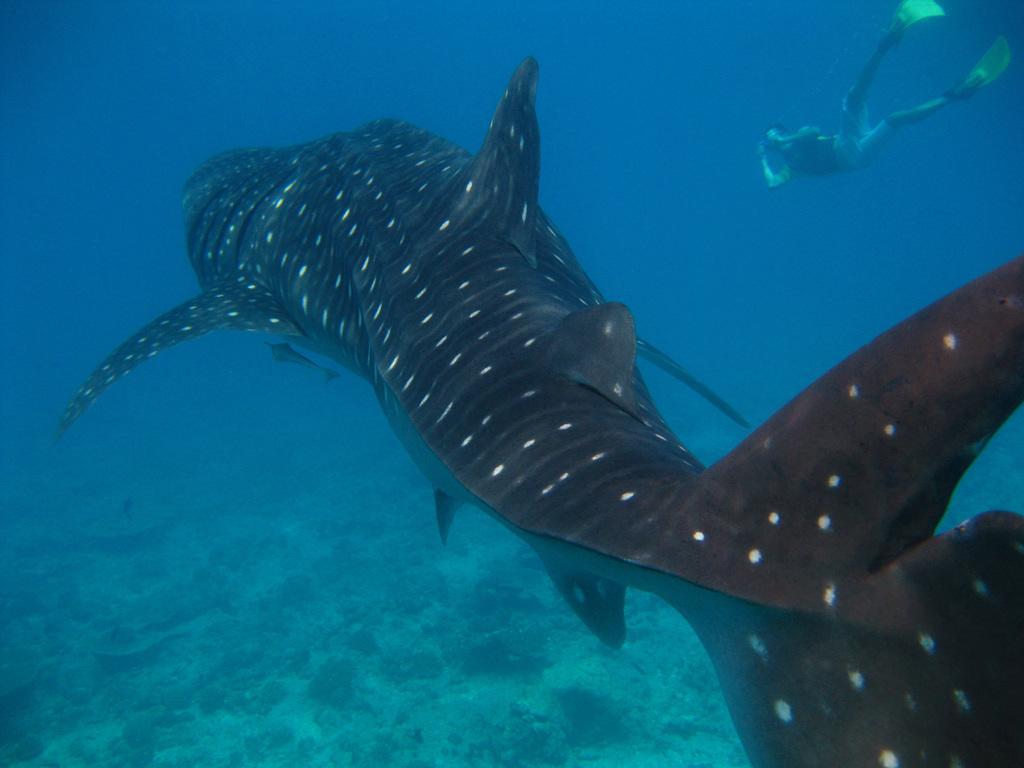Describe this image in one or two sentences. In this picture we can see a fish and a person in the water. 